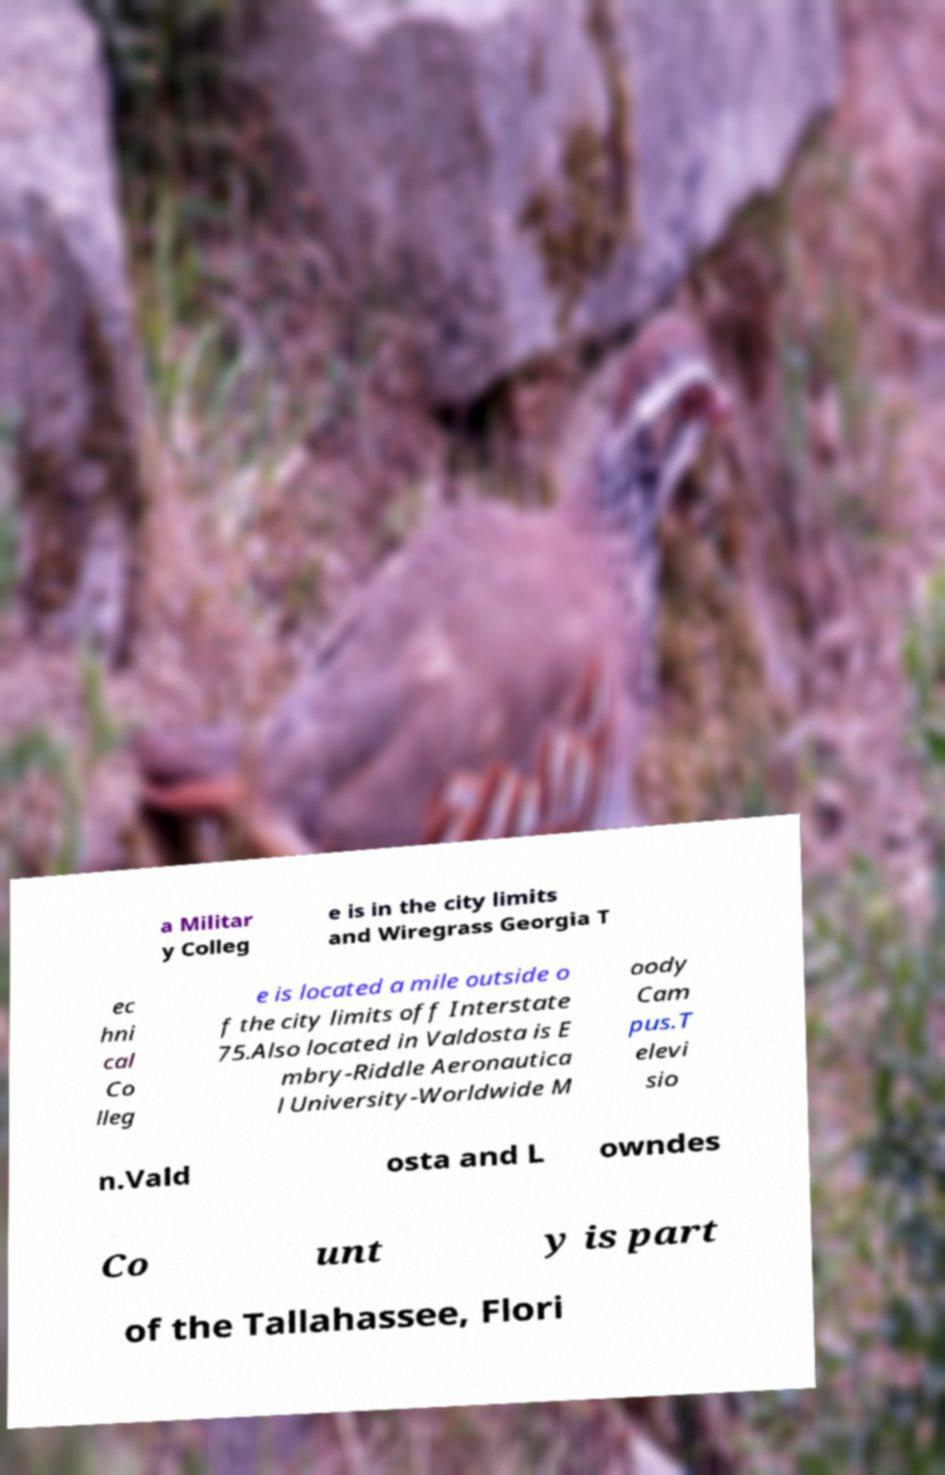Could you extract and type out the text from this image? a Militar y Colleg e is in the city limits and Wiregrass Georgia T ec hni cal Co lleg e is located a mile outside o f the city limits off Interstate 75.Also located in Valdosta is E mbry-Riddle Aeronautica l University-Worldwide M oody Cam pus.T elevi sio n.Vald osta and L owndes Co unt y is part of the Tallahassee, Flori 